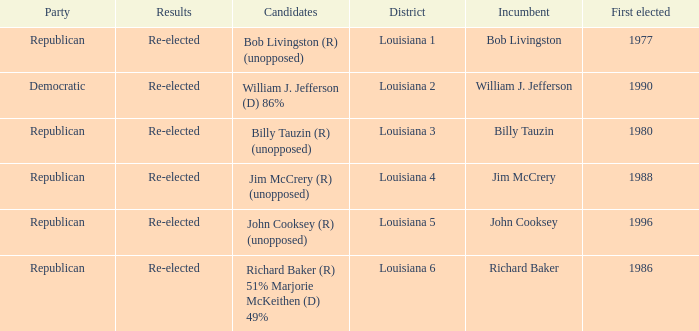Would you mind parsing the complete table? {'header': ['Party', 'Results', 'Candidates', 'District', 'Incumbent', 'First elected'], 'rows': [['Republican', 'Re-elected', 'Bob Livingston (R) (unopposed)', 'Louisiana 1', 'Bob Livingston', '1977'], ['Democratic', 'Re-elected', 'William J. Jefferson (D) 86%', 'Louisiana 2', 'William J. Jefferson', '1990'], ['Republican', 'Re-elected', 'Billy Tauzin (R) (unopposed)', 'Louisiana 3', 'Billy Tauzin', '1980'], ['Republican', 'Re-elected', 'Jim McCrery (R) (unopposed)', 'Louisiana 4', 'Jim McCrery', '1988'], ['Republican', 'Re-elected', 'John Cooksey (R) (unopposed)', 'Louisiana 5', 'John Cooksey', '1996'], ['Republican', 'Re-elected', 'Richard Baker (R) 51% Marjorie McKeithen (D) 49%', 'Louisiana 6', 'Richard Baker', '1986']]} What party does William J. Jefferson? Democratic. 